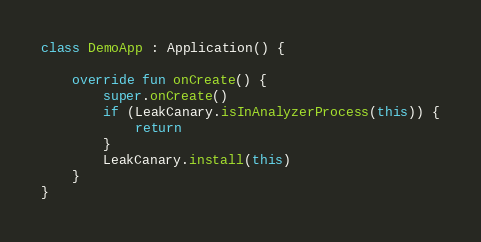Convert code to text. <code><loc_0><loc_0><loc_500><loc_500><_Kotlin_>class DemoApp : Application() {

    override fun onCreate() {
        super.onCreate()
        if (LeakCanary.isInAnalyzerProcess(this)) {
            return
        }
        LeakCanary.install(this)
    }
}
</code> 